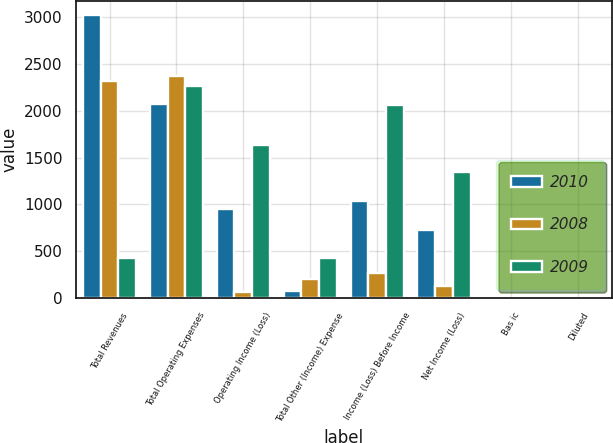Convert chart to OTSL. <chart><loc_0><loc_0><loc_500><loc_500><stacked_bar_chart><ecel><fcel>Total Revenues<fcel>Total Operating Expenses<fcel>Operating Income (Loss)<fcel>Total Other (Income) Expense<fcel>Income (Loss) Before Income<fcel>Net Income (Loss)<fcel>Bas ic<fcel>Diluted<nl><fcel>2010<fcel>3022<fcel>2070<fcel>952<fcel>79<fcel>1031<fcel>725<fcel>4.15<fcel>4.1<nl><fcel>2008<fcel>2313<fcel>2371<fcel>58<fcel>206<fcel>264<fcel>131<fcel>0.75<fcel>0.75<nl><fcel>2009<fcel>426<fcel>2266<fcel>1635<fcel>426<fcel>2061<fcel>1350<fcel>7.83<fcel>7.58<nl></chart> 